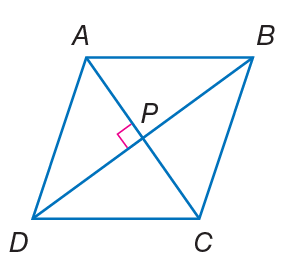Answer the mathemtical geometry problem and directly provide the correct option letter.
Question: Quadrilateral A B C D is a rhombus. If m \angle A B C = 2 x - 7 and m \angle B C D = 2 x + 3, find m \angle D A B.
Choices: A: 33 B: 50 C: 95 D: 120 C 